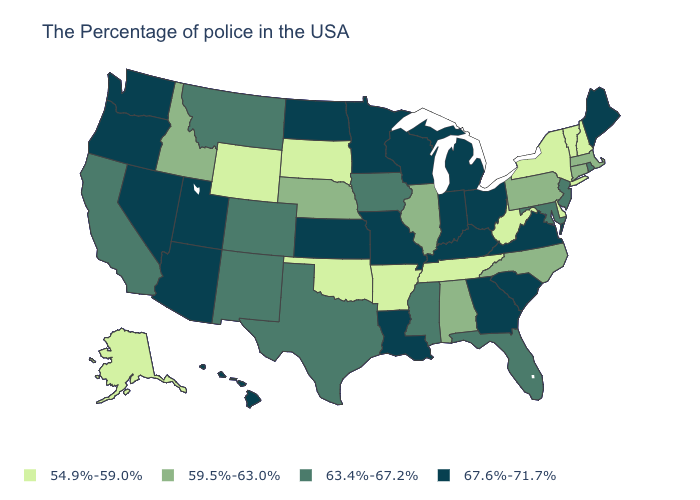Does the map have missing data?
Concise answer only. No. Does the first symbol in the legend represent the smallest category?
Write a very short answer. Yes. What is the value of Oregon?
Be succinct. 67.6%-71.7%. Name the states that have a value in the range 67.6%-71.7%?
Quick response, please. Maine, Virginia, South Carolina, Ohio, Georgia, Michigan, Kentucky, Indiana, Wisconsin, Louisiana, Missouri, Minnesota, Kansas, North Dakota, Utah, Arizona, Nevada, Washington, Oregon, Hawaii. Which states have the lowest value in the USA?
Give a very brief answer. New Hampshire, Vermont, New York, Delaware, West Virginia, Tennessee, Arkansas, Oklahoma, South Dakota, Wyoming, Alaska. How many symbols are there in the legend?
Answer briefly. 4. Does the map have missing data?
Quick response, please. No. Name the states that have a value in the range 63.4%-67.2%?
Short answer required. Rhode Island, New Jersey, Maryland, Florida, Mississippi, Iowa, Texas, Colorado, New Mexico, Montana, California. What is the value of Illinois?
Quick response, please. 59.5%-63.0%. What is the value of Oregon?
Write a very short answer. 67.6%-71.7%. Name the states that have a value in the range 54.9%-59.0%?
Quick response, please. New Hampshire, Vermont, New York, Delaware, West Virginia, Tennessee, Arkansas, Oklahoma, South Dakota, Wyoming, Alaska. What is the value of Ohio?
Short answer required. 67.6%-71.7%. What is the value of North Carolina?
Short answer required. 59.5%-63.0%. Which states have the lowest value in the USA?
Be succinct. New Hampshire, Vermont, New York, Delaware, West Virginia, Tennessee, Arkansas, Oklahoma, South Dakota, Wyoming, Alaska. Name the states that have a value in the range 59.5%-63.0%?
Write a very short answer. Massachusetts, Connecticut, Pennsylvania, North Carolina, Alabama, Illinois, Nebraska, Idaho. 